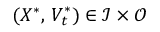Convert formula to latex. <formula><loc_0><loc_0><loc_500><loc_500>( X ^ { \ast } , \, V _ { t } ^ { \ast } ) \in \mathcal { I } \times \mathcal { O }</formula> 